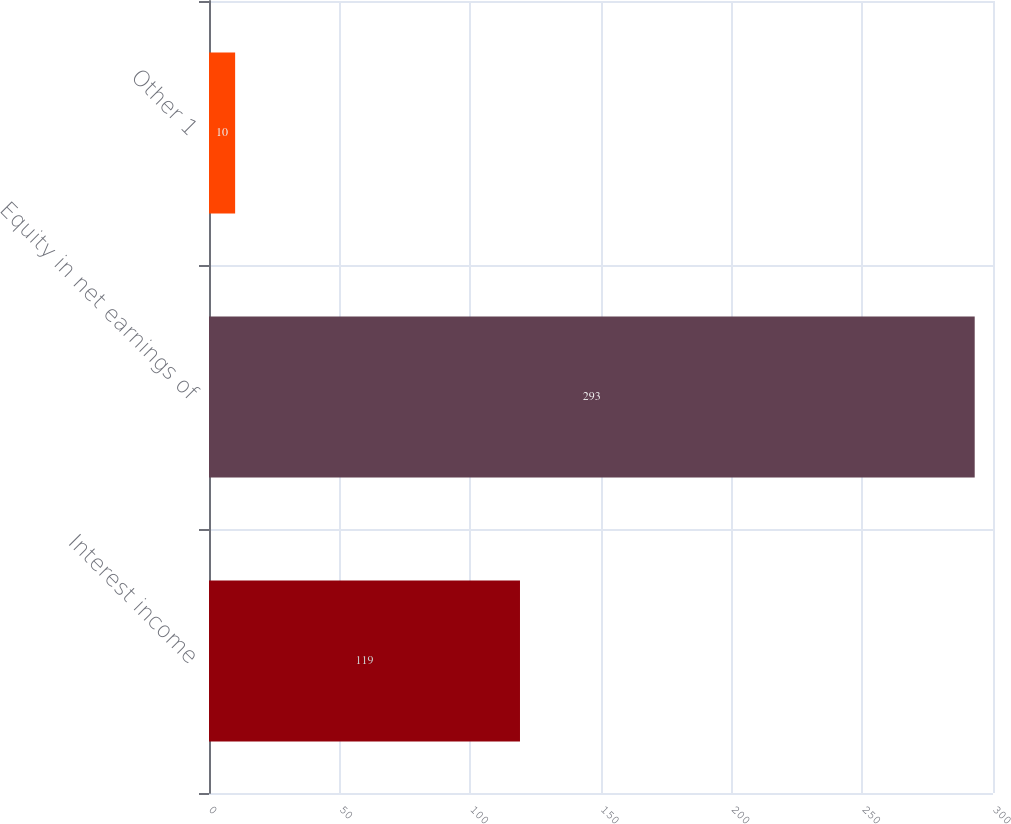Convert chart. <chart><loc_0><loc_0><loc_500><loc_500><bar_chart><fcel>Interest income<fcel>Equity in net earnings of<fcel>Other 1<nl><fcel>119<fcel>293<fcel>10<nl></chart> 